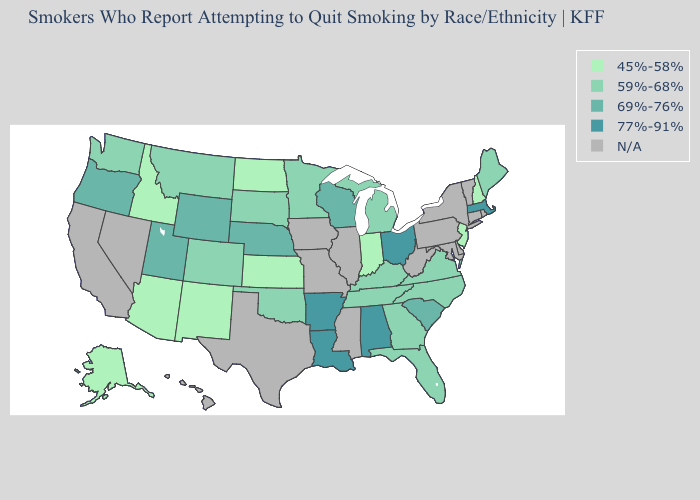What is the highest value in states that border Illinois?
Quick response, please. 69%-76%. Does Ohio have the highest value in the USA?
Quick response, please. Yes. Does the map have missing data?
Give a very brief answer. Yes. What is the value of Tennessee?
Keep it brief. 59%-68%. What is the value of Utah?
Keep it brief. 69%-76%. Among the states that border Nebraska , which have the lowest value?
Short answer required. Kansas. Name the states that have a value in the range 59%-68%?
Concise answer only. Colorado, Florida, Georgia, Kentucky, Maine, Michigan, Minnesota, Montana, North Carolina, Oklahoma, South Dakota, Tennessee, Virginia, Washington. What is the highest value in the Northeast ?
Short answer required. 77%-91%. Which states have the highest value in the USA?
Short answer required. Alabama, Arkansas, Louisiana, Massachusetts, Ohio. What is the value of South Dakota?
Short answer required. 59%-68%. Among the states that border Florida , which have the highest value?
Write a very short answer. Alabama. What is the value of Maine?
Answer briefly. 59%-68%. What is the lowest value in the West?
Concise answer only. 45%-58%. Which states have the highest value in the USA?
Quick response, please. Alabama, Arkansas, Louisiana, Massachusetts, Ohio. 